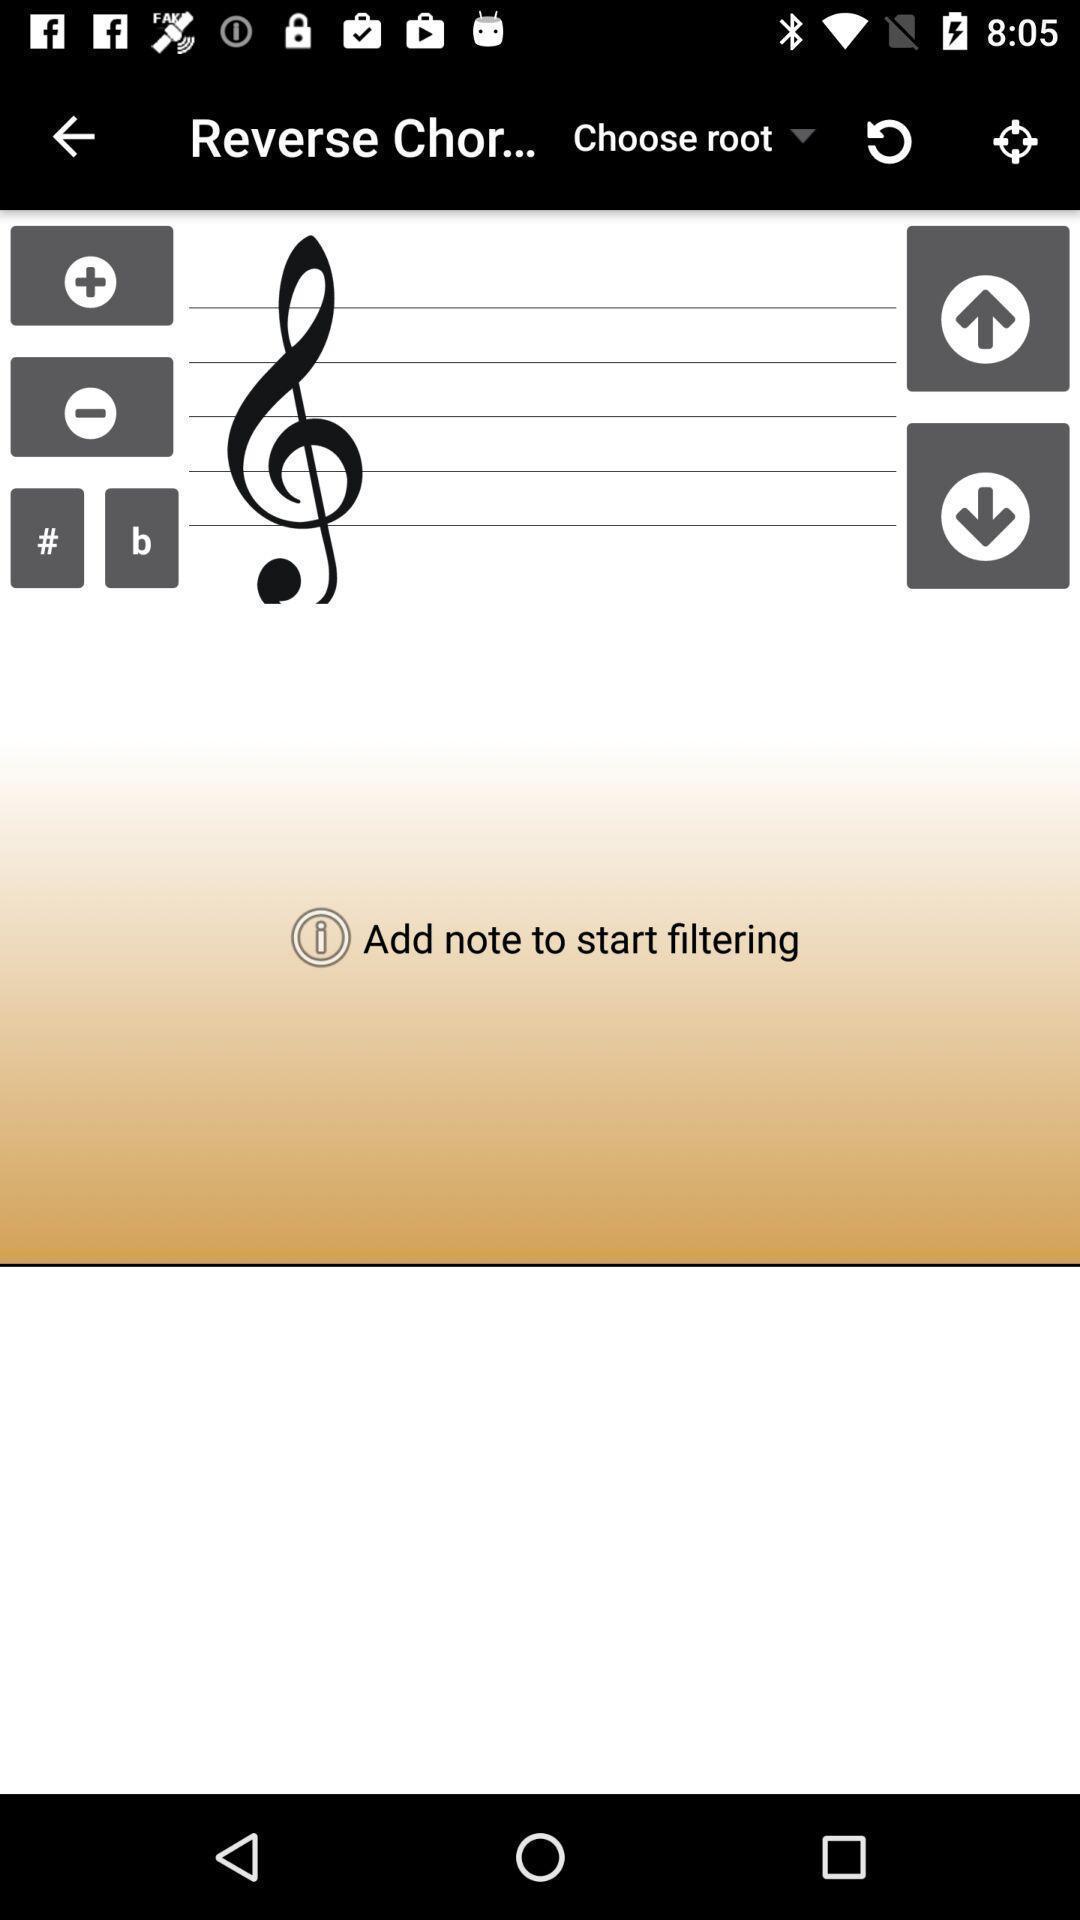What is the overall content of this screenshot? Screen displaying page of an musical application. 